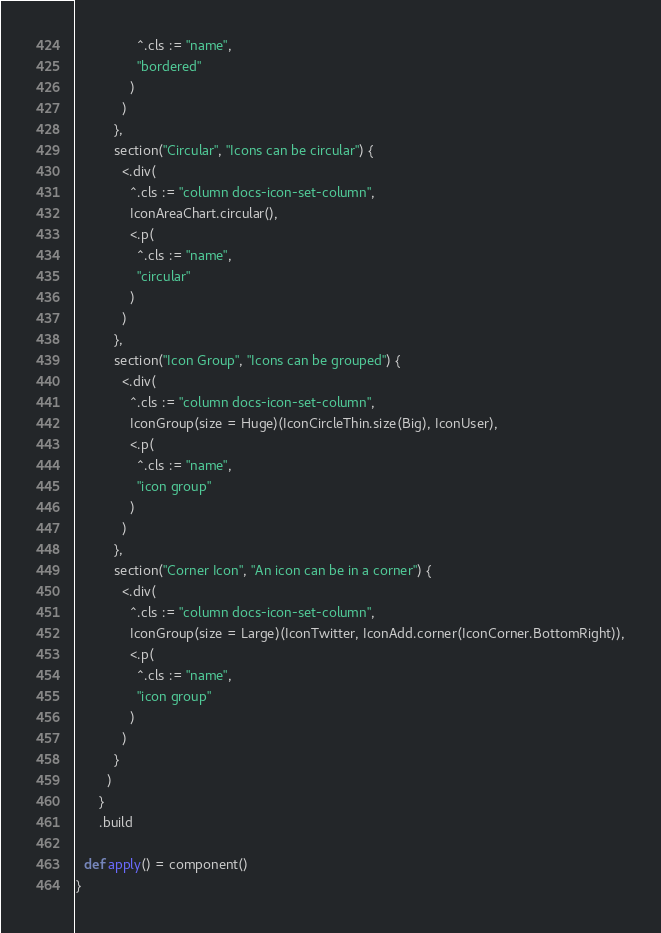Convert code to text. <code><loc_0><loc_0><loc_500><loc_500><_Scala_>                ^.cls := "name",
                "bordered"
              )
            )
          },
          section("Circular", "Icons can be circular") {
            <.div(
              ^.cls := "column docs-icon-set-column",
              IconAreaChart.circular(),
              <.p(
                ^.cls := "name",
                "circular"
              )
            )
          },
          section("Icon Group", "Icons can be grouped") {
            <.div(
              ^.cls := "column docs-icon-set-column",
              IconGroup(size = Huge)(IconCircleThin.size(Big), IconUser),
              <.p(
                ^.cls := "name",
                "icon group"
              )
            )
          },
          section("Corner Icon", "An icon can be in a corner") {
            <.div(
              ^.cls := "column docs-icon-set-column",
              IconGroup(size = Large)(IconTwitter, IconAdd.corner(IconCorner.BottomRight)),
              <.p(
                ^.cls := "name",
                "icon group"
              )
            )
          }
        )
      }
      .build

  def apply() = component()
}
</code> 